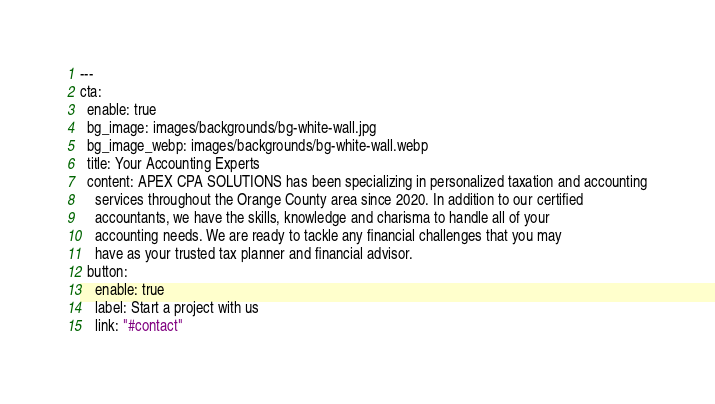<code> <loc_0><loc_0><loc_500><loc_500><_YAML_>---
cta:
  enable: true
  bg_image: images/backgrounds/bg-white-wall.jpg
  bg_image_webp: images/backgrounds/bg-white-wall.webp
  title: Your Accounting Experts
  content: APEX CPA SOLUTIONS has been specializing in personalized taxation and accounting
    services throughout the Orange County area since 2020. In addition to our certified
    accountants, we have the skills, knowledge and charisma to handle all of your
    accounting needs. We are ready to tackle any financial challenges that you may
    have as your trusted tax planner and financial advisor.
  button:
    enable: true
    label: Start a project with us
    link: "#contact"
</code> 